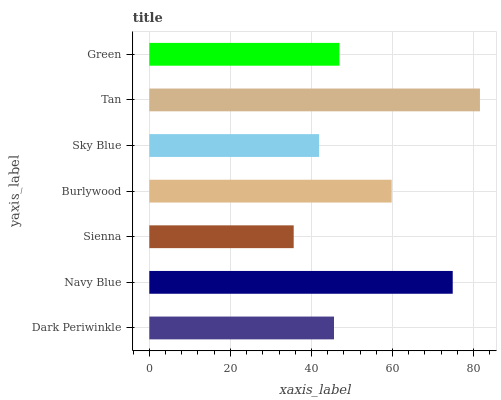Is Sienna the minimum?
Answer yes or no. Yes. Is Tan the maximum?
Answer yes or no. Yes. Is Navy Blue the minimum?
Answer yes or no. No. Is Navy Blue the maximum?
Answer yes or no. No. Is Navy Blue greater than Dark Periwinkle?
Answer yes or no. Yes. Is Dark Periwinkle less than Navy Blue?
Answer yes or no. Yes. Is Dark Periwinkle greater than Navy Blue?
Answer yes or no. No. Is Navy Blue less than Dark Periwinkle?
Answer yes or no. No. Is Green the high median?
Answer yes or no. Yes. Is Green the low median?
Answer yes or no. Yes. Is Sky Blue the high median?
Answer yes or no. No. Is Navy Blue the low median?
Answer yes or no. No. 